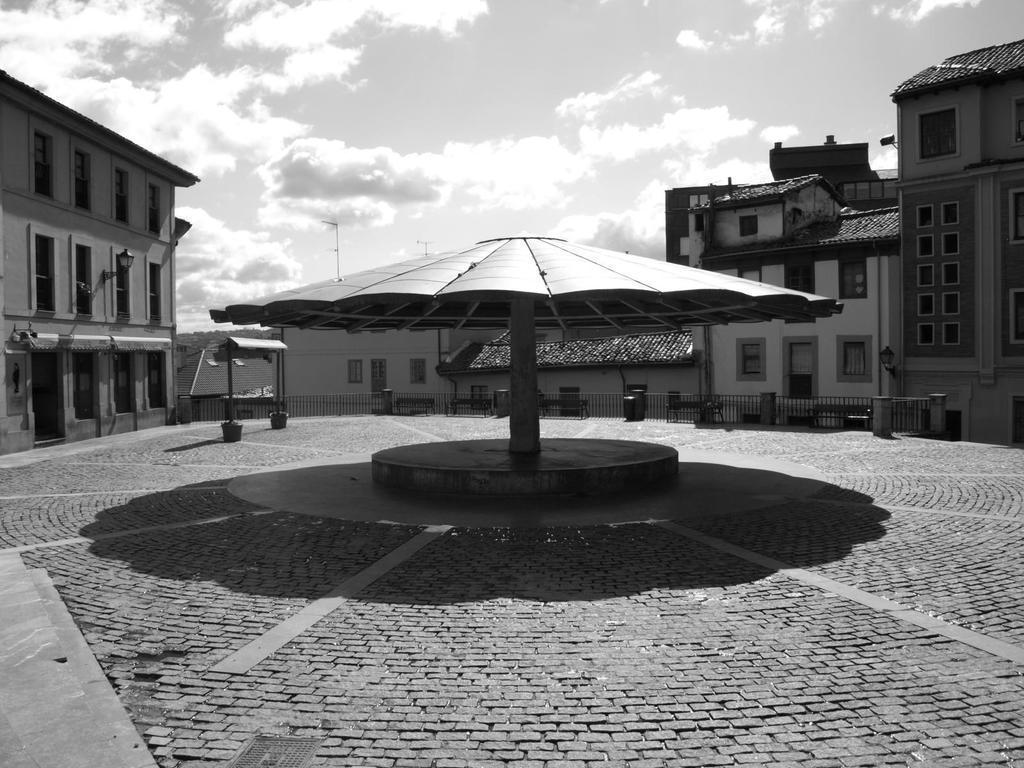Can you describe this image briefly? In this picture we can see the ground, shelter, fence, benches, buildings with windows, some objects and in the background we can see the sky with clouds. 